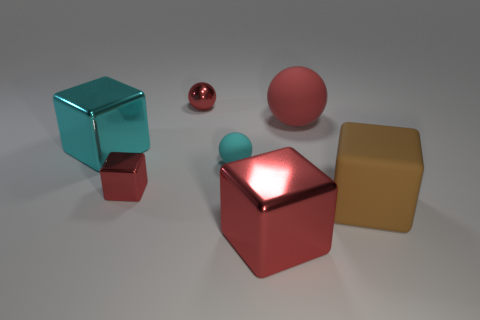Subtract 1 blocks. How many blocks are left? 3 Add 2 large rubber things. How many objects exist? 9 Subtract all blocks. How many objects are left? 3 Add 7 shiny balls. How many shiny balls are left? 8 Add 1 big cyan matte cylinders. How many big cyan matte cylinders exist? 1 Subtract 0 gray cylinders. How many objects are left? 7 Subtract all big metallic blocks. Subtract all cyan rubber objects. How many objects are left? 4 